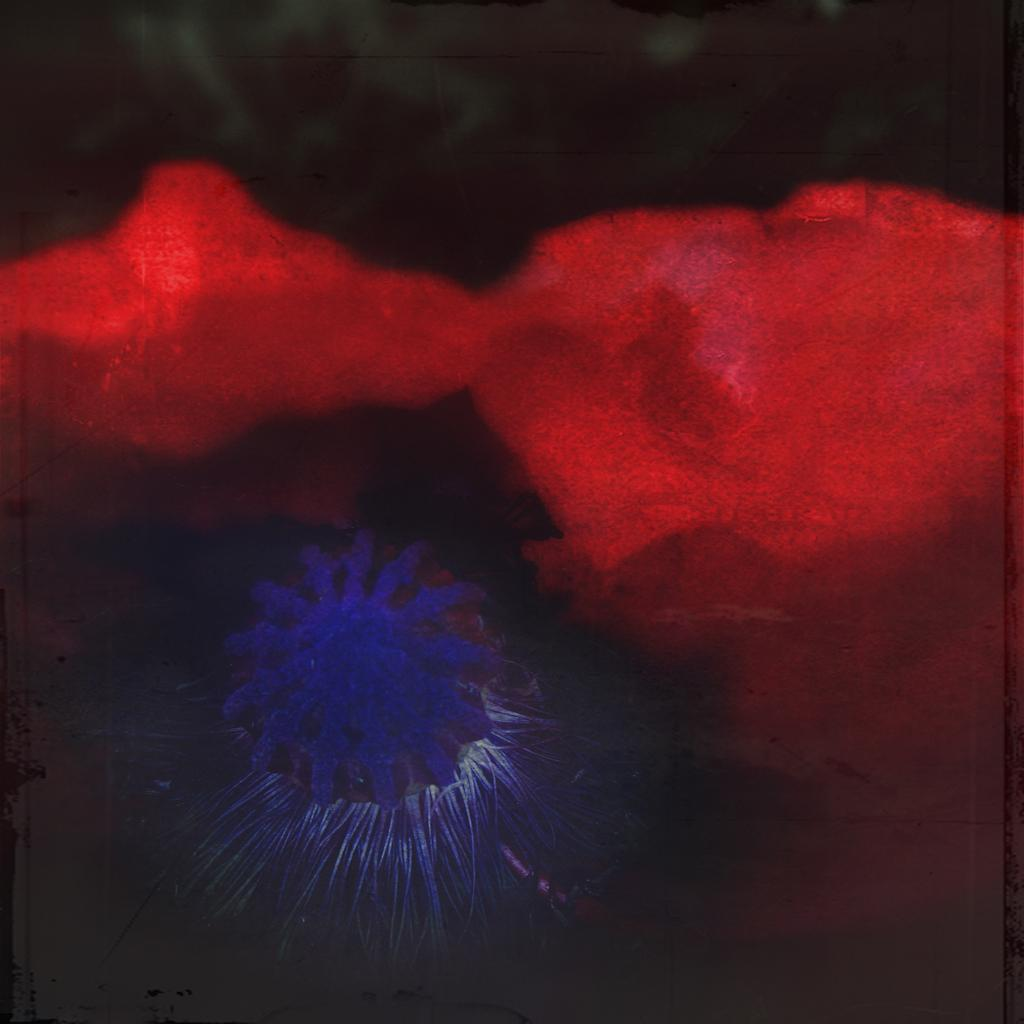What color can be seen on some of the objects in the image? There are red colored objects in the image. Can you describe any other color present in the image? There is a blue colored object in the image. What is the appearance of the background in the image? The background of the image is blurred. What time of day is it in the image, specifically in the afternoon? The time of day is not mentioned or depicted in the image, so it cannot be determined if it is specifically in the afternoon. 